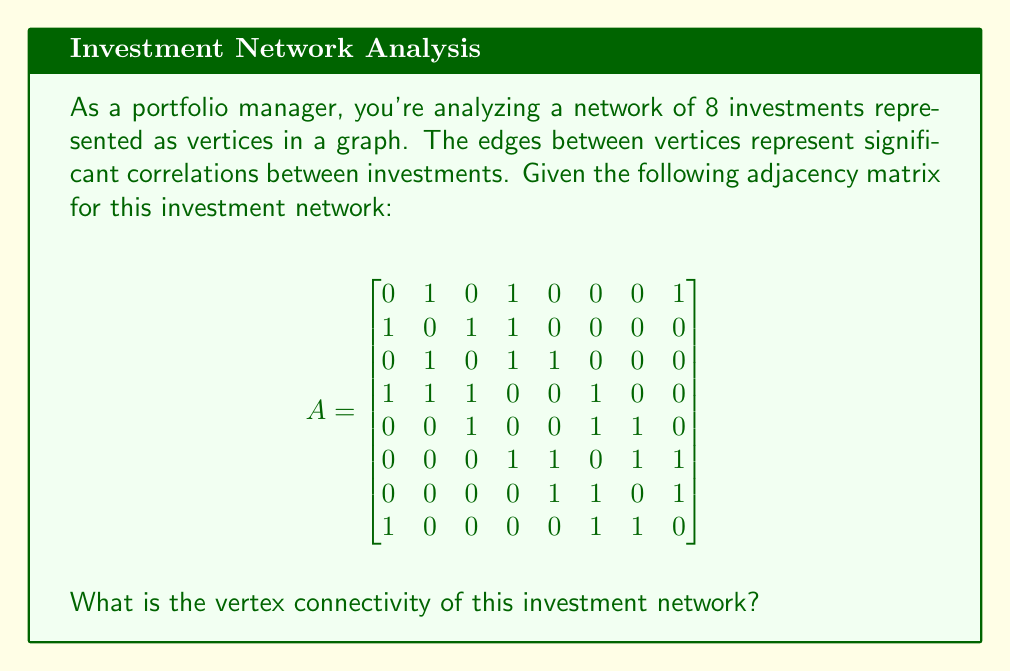Can you answer this question? To find the vertex connectivity of the graph, we need to determine the minimum number of vertices that need to be removed to disconnect the graph. Let's approach this step-by-step:

1) First, we need to understand what vertex connectivity means. The vertex connectivity of a graph is the minimum number of vertices that need to be removed to disconnect the graph or reduce it to a single vertex.

2) We can start by looking at the degree of each vertex. The vertex with the lowest degree might be a good candidate for disconnecting the graph:

   Vertex 1: degree 3
   Vertex 2: degree 3
   Vertex 3: degree 3
   Vertex 4: degree 4
   Vertex 5: degree 3
   Vertex 6: degree 4
   Vertex 7: degree 3
   Vertex 8: degree 3

3) We can see that most vertices have a degree of 3, which means removing any single vertex will not disconnect the graph.

4) Let's try removing two vertices. We should focus on vertices that are not directly connected and have lower degrees. For example, let's try removing vertices 1 and 3:

   - After removing 1 and 3, we're left with vertices 2, 4, 5, 6, 7, and 8.
   - Checking the remaining connections, we can see that the graph is still connected.

5) We need to try removing three vertices. Let's remove vertices 1, 3, and 5:

   - After removing 1, 3, and 5, we're left with vertices 2, 4, 6, 7, and 8.
   - Checking the remaining connections, we can see that the graph is now disconnected. Vertex 2 is isolated from the rest.

6) We have found that removing three carefully chosen vertices can disconnect the graph, and we couldn't do it with fewer vertices.

Therefore, the vertex connectivity of this investment network is 3.
Answer: The vertex connectivity of the investment network is 3. 